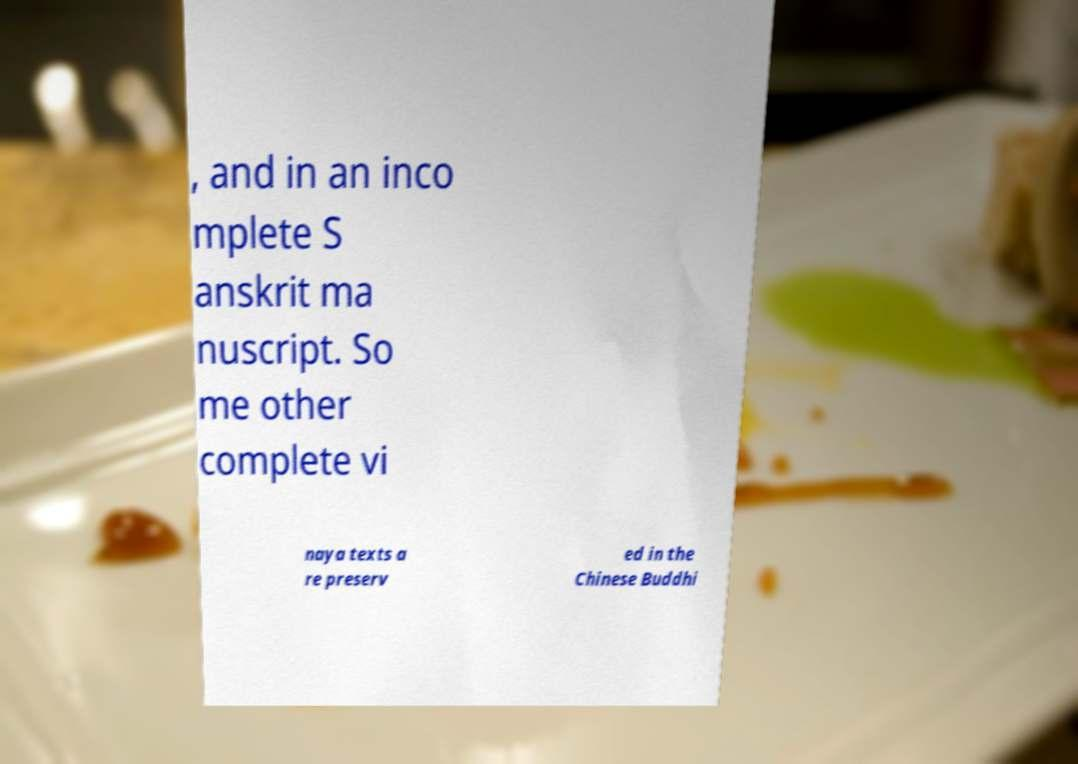Could you extract and type out the text from this image? , and in an inco mplete S anskrit ma nuscript. So me other complete vi naya texts a re preserv ed in the Chinese Buddhi 